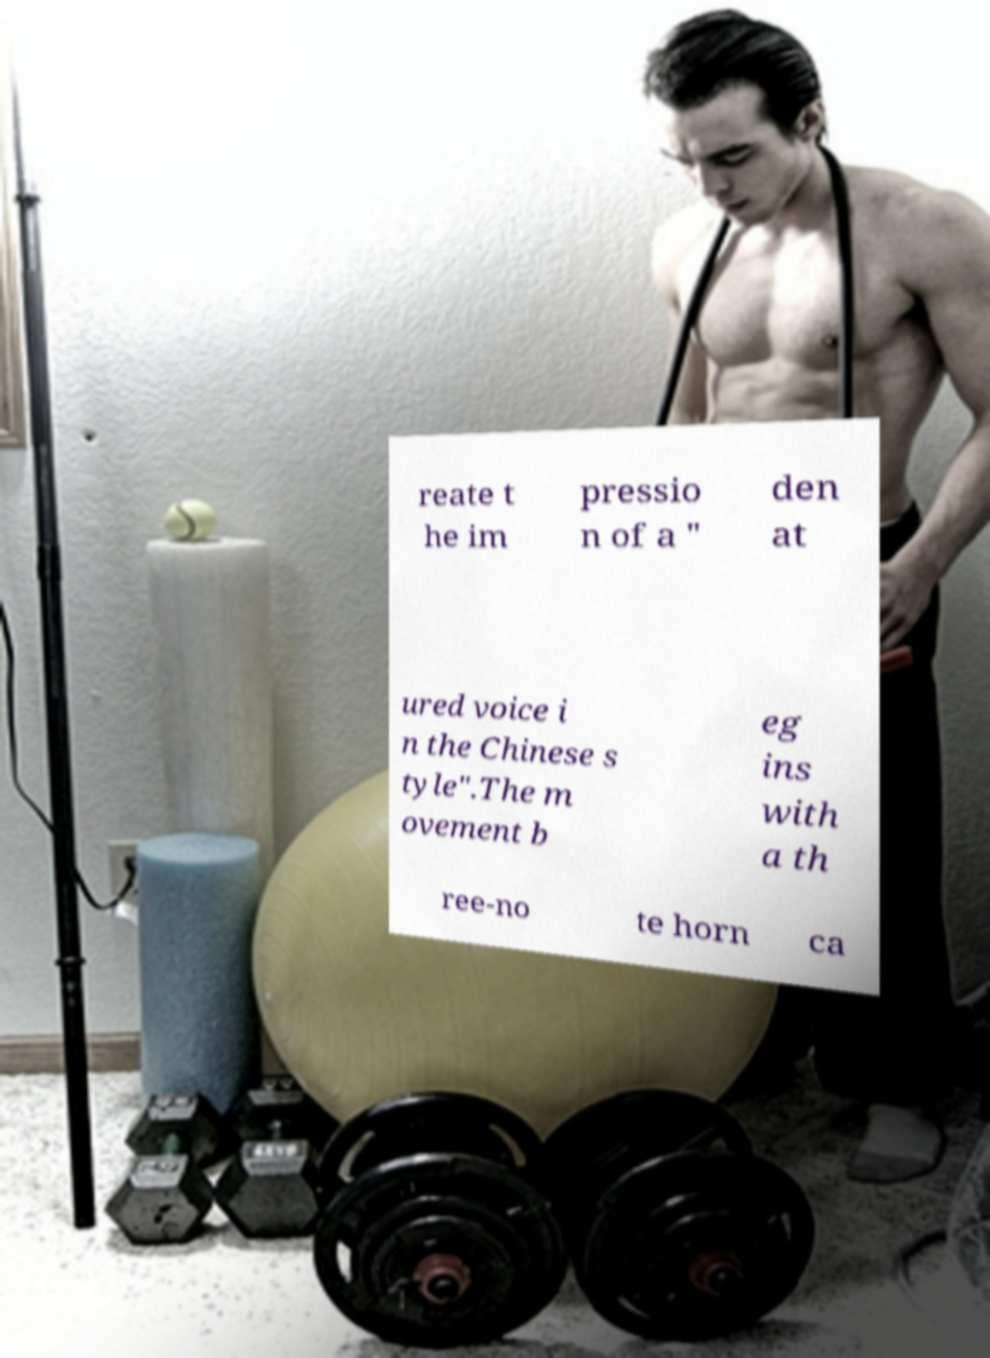Could you assist in decoding the text presented in this image and type it out clearly? reate t he im pressio n of a " den at ured voice i n the Chinese s tyle".The m ovement b eg ins with a th ree-no te horn ca 